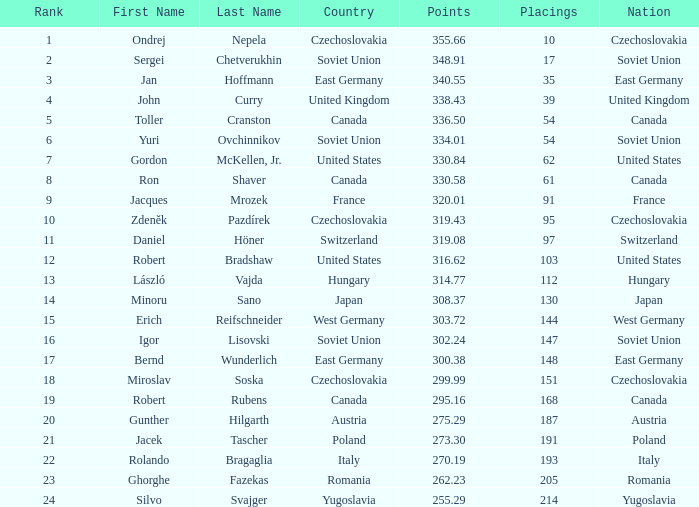Which rankings have a nation of west germany, and scores exceeding 30 None. 